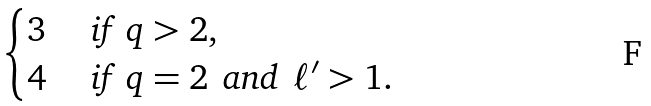Convert formula to latex. <formula><loc_0><loc_0><loc_500><loc_500>\begin{cases} 3 & \text { if } \, q > 2 , \\ 4 & \text { if } \, q = 2 \, \text { and } \, \ell ^ { \prime } > 1 . \end{cases}</formula> 